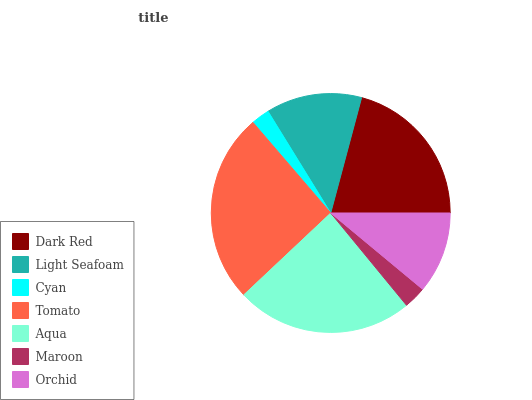Is Cyan the minimum?
Answer yes or no. Yes. Is Tomato the maximum?
Answer yes or no. Yes. Is Light Seafoam the minimum?
Answer yes or no. No. Is Light Seafoam the maximum?
Answer yes or no. No. Is Dark Red greater than Light Seafoam?
Answer yes or no. Yes. Is Light Seafoam less than Dark Red?
Answer yes or no. Yes. Is Light Seafoam greater than Dark Red?
Answer yes or no. No. Is Dark Red less than Light Seafoam?
Answer yes or no. No. Is Light Seafoam the high median?
Answer yes or no. Yes. Is Light Seafoam the low median?
Answer yes or no. Yes. Is Orchid the high median?
Answer yes or no. No. Is Tomato the low median?
Answer yes or no. No. 